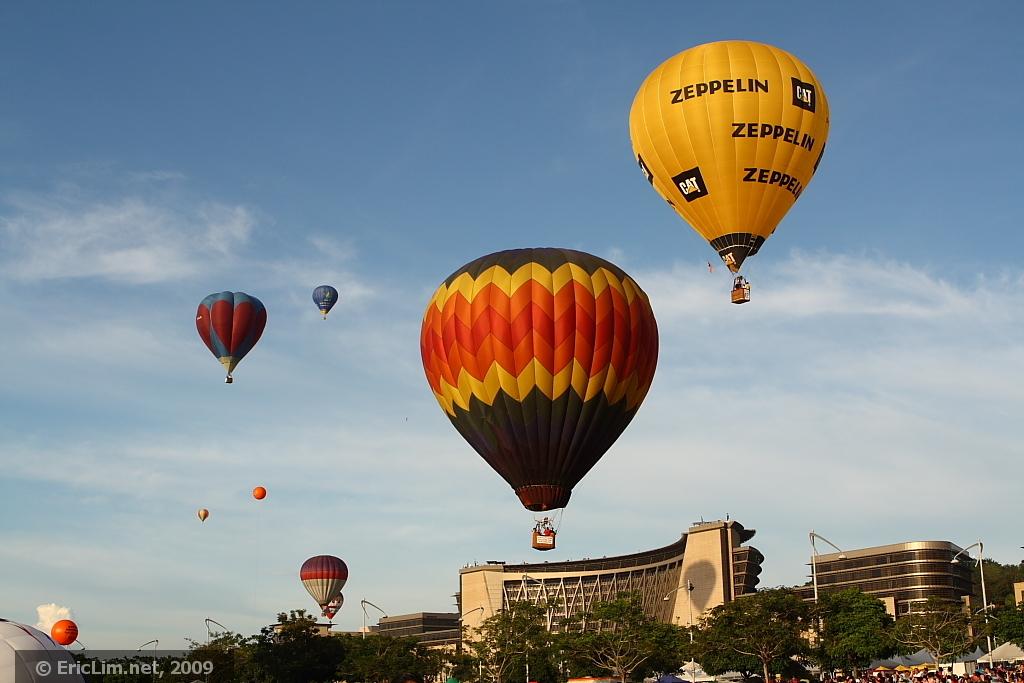What does the orange balloon say?
Offer a very short reply. Zeppelin. What year was this picture taken?
Ensure brevity in your answer.  2009. 